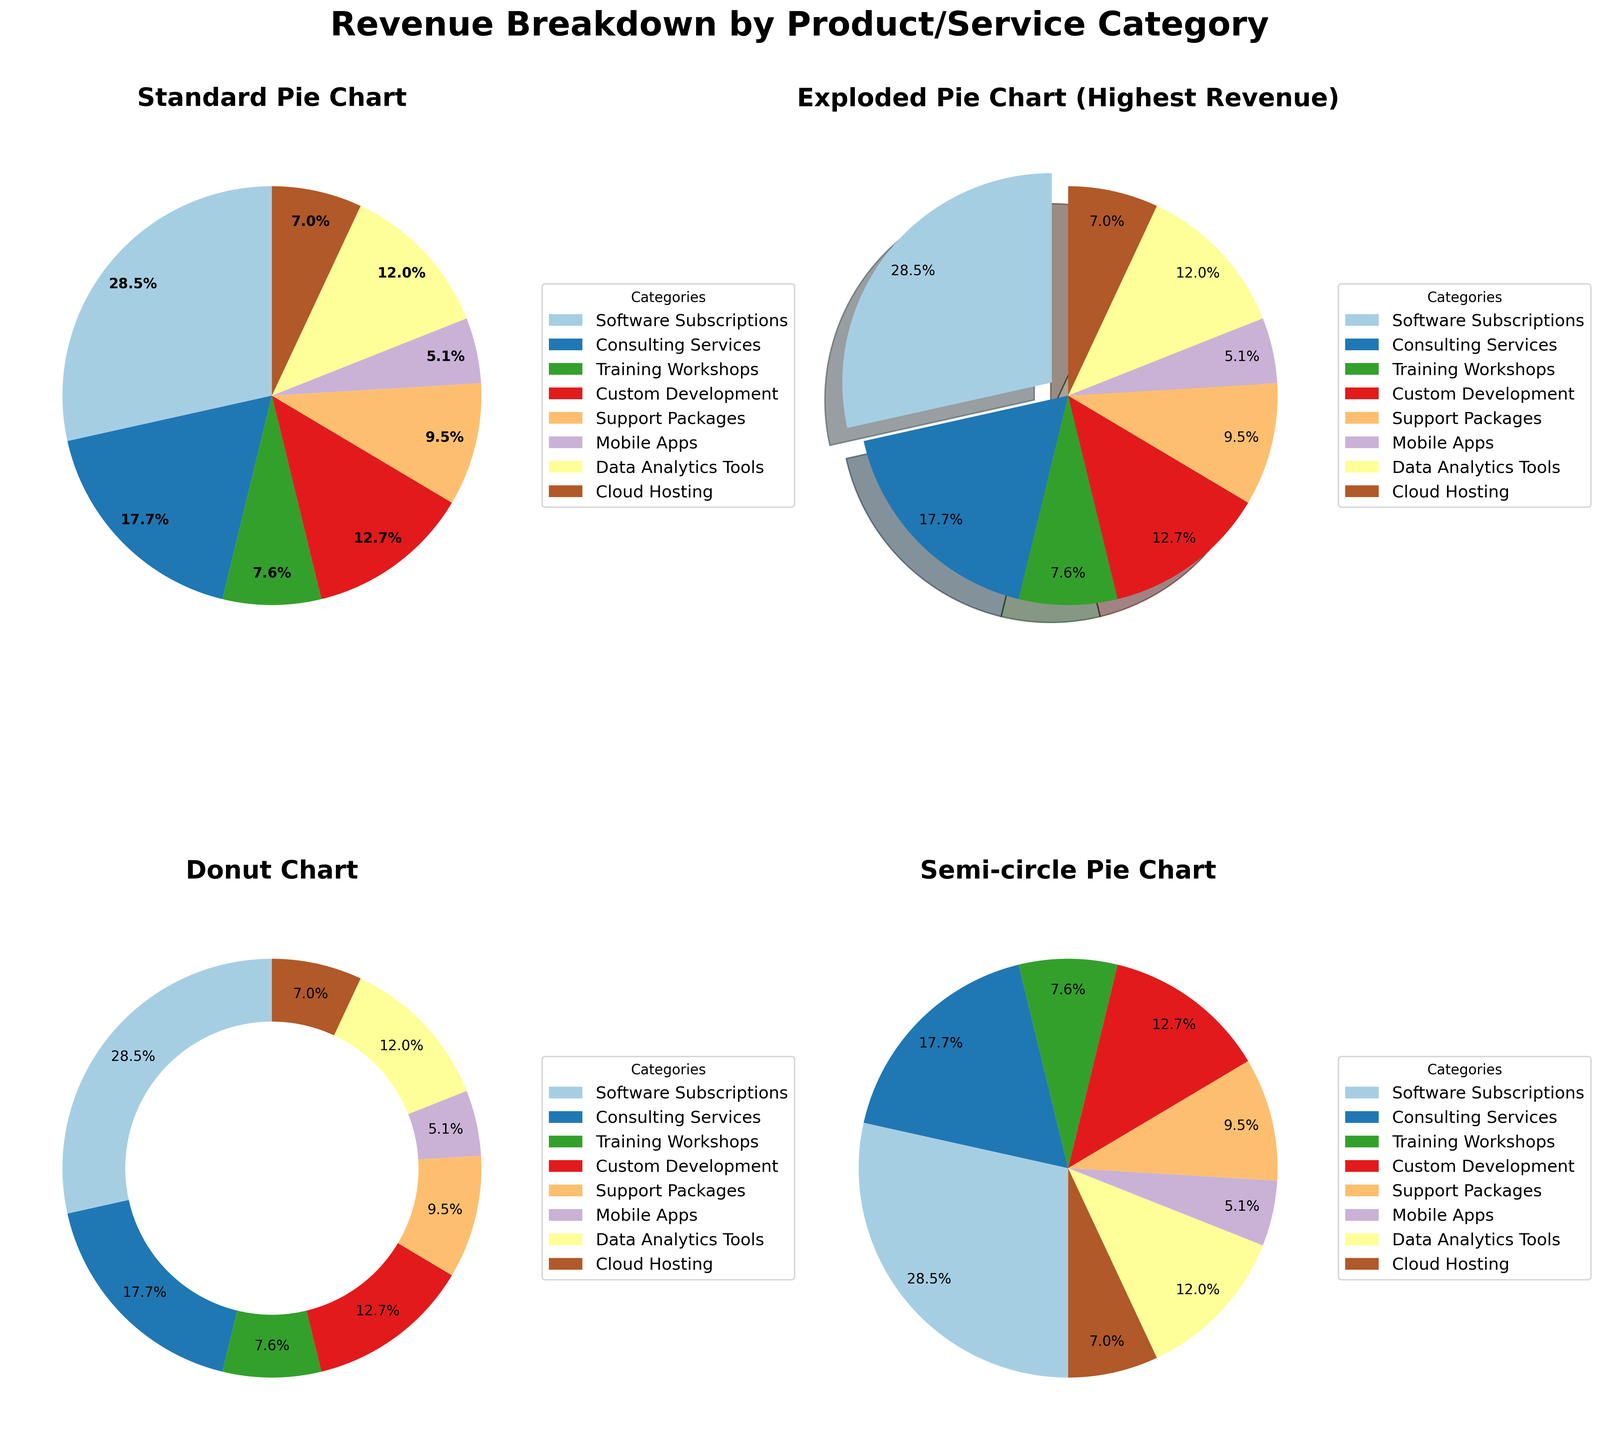What category has the highest revenue? By examining all four pie charts, it can be observed that 'Software Subscriptions' has the largest slice, indicating the highest revenue among all categories.
Answer: Software Subscriptions What is the total revenue generated by 'Training Workshops' and 'Mobile Apps'? From the data, the revenue from 'Training Workshops' is 120,000 and from 'Mobile Apps' is 80,000. Adding these together: 120,000 + 80,000 = 200,000.
Answer: 200,000 Which category has the smallest revenue share in the Donut Chart? All charts indicate that 'Mobile Apps' has the smallest pie slice, making it the smallest revenue share in the Donut Chart as well.
Answer: Mobile Apps How does the revenue of 'Consulting Services' compare to 'Support Packages'? The revenue of 'Consulting Services' is 280,000 and 'Support Packages' is 150,000. Comparing these, 280,000 is greater than 150,000.
Answer: Consulting Services is greater Which category is emphasized in the Exploded Pie Chart and why? The Exploded Pie Chart emphasizes 'Software Subscriptions' by separating its slice from the rest. This is done to highlight that it has the highest revenue.
Answer: Software Subscriptions How many categories are represented in each pie chart? Each pie chart has all categories represented, and there are a total of eight categories visible.
Answer: Eight Is 'Cloud Hosting' revenue more significant than 'Custom Development' revenue? The revenue of 'Cloud Hosting' is 110,000, while 'Custom Development' is 200,000. Therefore, 'Cloud Hosting' revenue is less than 'Custom Development' revenue.
Answer: No Are the percentage labels in each pie chart consistent with the respective category sizes? The percentage labels reflect the revenue proportions accurately, as observed from the size of each pie slice. For example, the largest slice ('Software Subscriptions') corroborates its highest percentage label.
Answer: Yes What title appears on the top of the subplots? The title 'Revenue Breakdown by Product/Service Category' is centered at the top of the	subplots.
Answer: Revenue Breakdown by Product/Service Category In the Semi-circle Pie Chart, which direction does the chart start from, and how does it differ from the other pie charts? The Semi-circle Pie Chart starts from -90 degrees (negative) and fills counterclockwise, unlike the other charts that start from 90 degrees and fill clockwise.
Answer: -90 degrees and counterclockwise 